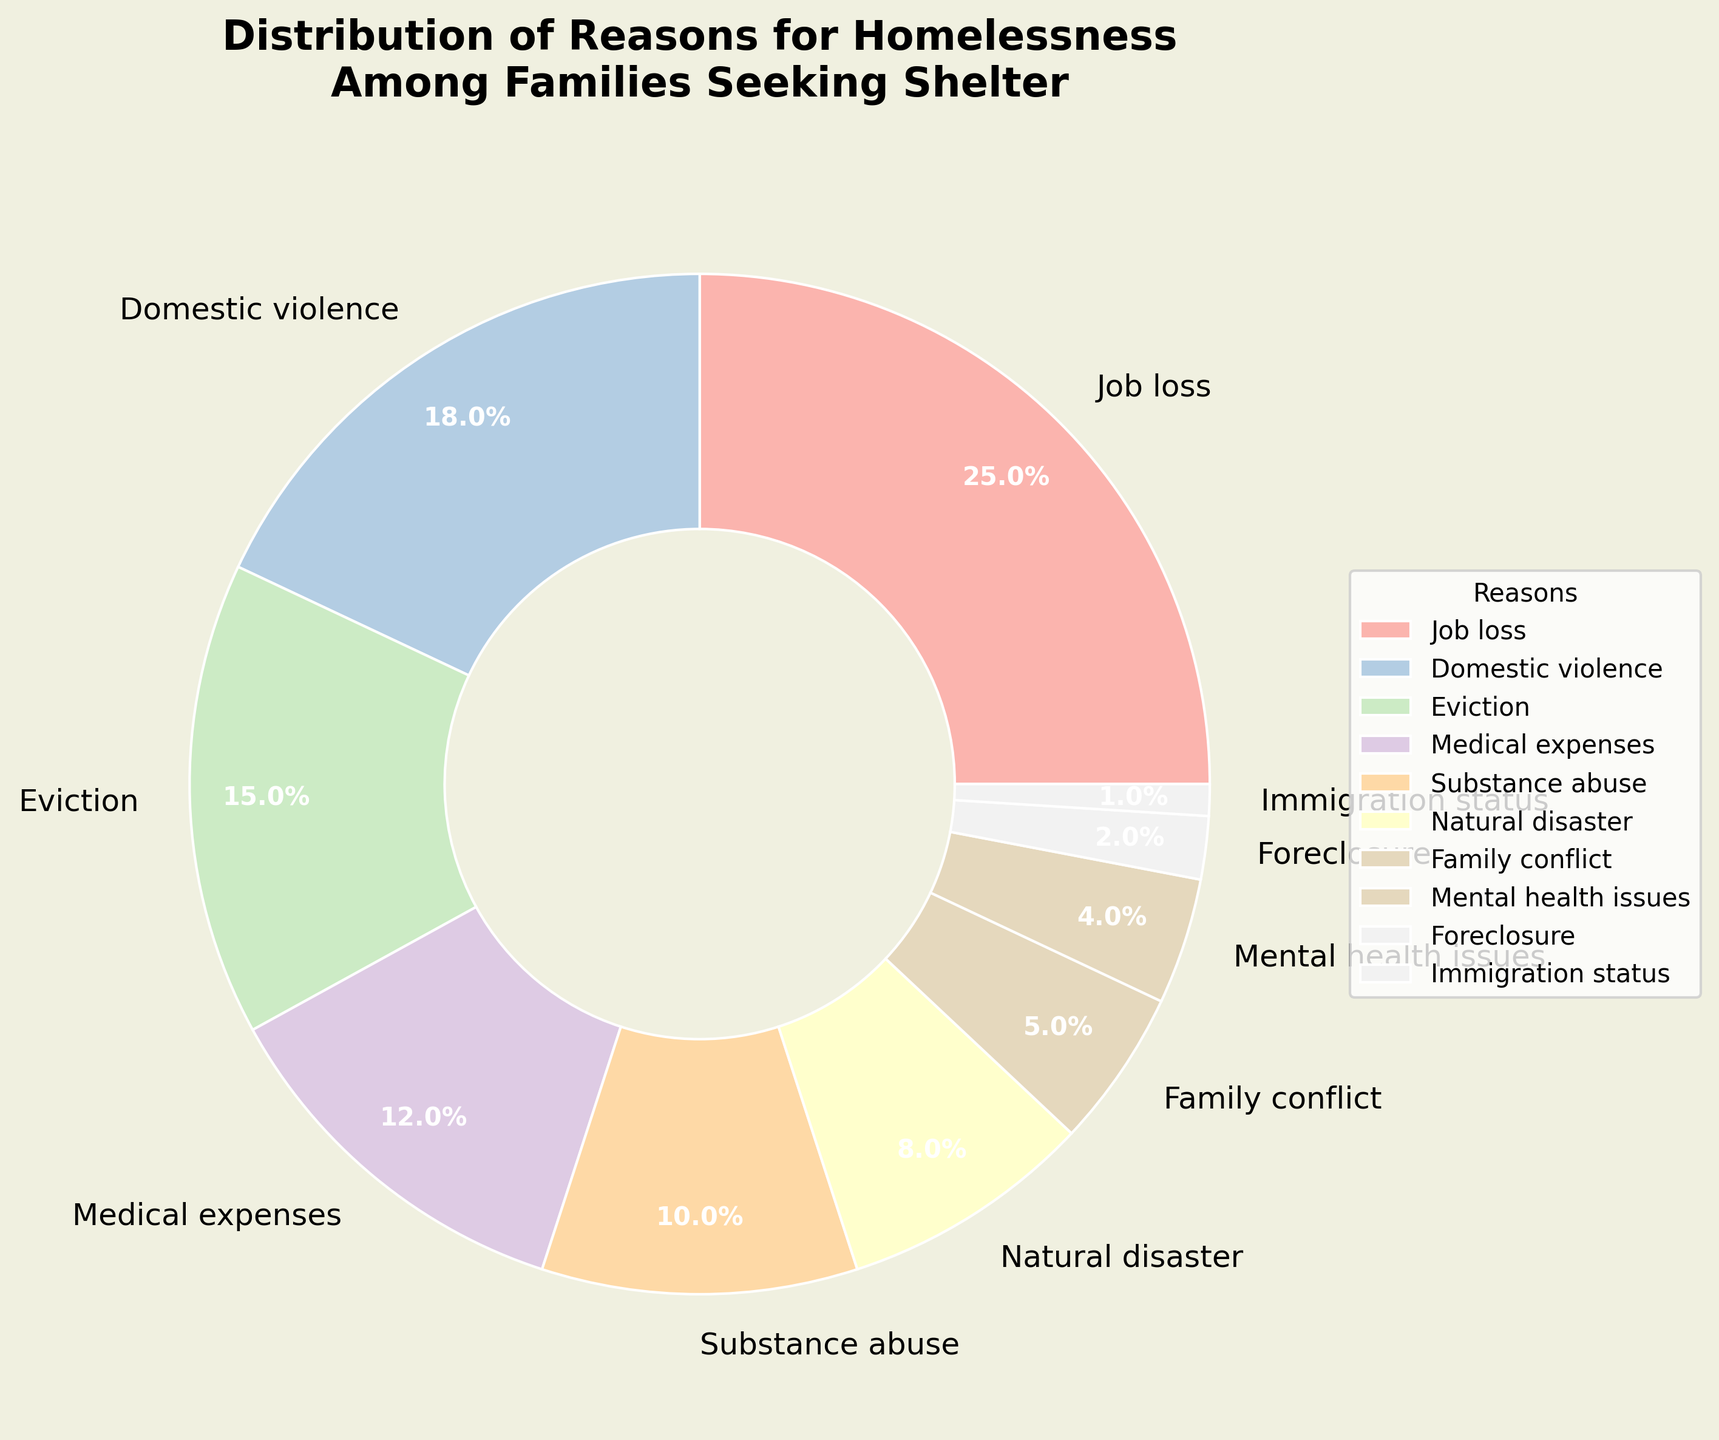What is the most common reason for homelessness among families seeking shelter? The most common reason will be the segment with the largest percentage on the pie chart. By looking at the figure, the segment labeled "Job loss" has the highest percentage at 25%.
Answer: Job loss What is the combined percentage of families experiencing homelessness due to medical expenses and natural disasters? We sum the percentages for medical expenses and natural disasters. According to the figure, medical expenses account for 12% and natural disasters 8%. So, the combined percentage is 12% + 8% = 20%.
Answer: 20% Which is more prevalent: eviction or substance abuse as a reason for homelessness? By comparing the percentages, eviction (15%) and substance abuse (10%), we see that eviction has a higher percentage.
Answer: Eviction What percentage of families are homeless due to reasons related to domestic violence or family conflict? Adding the percentages for domestic violence (18%) and family conflict (5%) results in 18% + 5% = 23%.
Answer: 23% Between mental health issues and immigration status, which reason affects fewer families? Comparing the percentages for mental health issues (4%) and immigration status (1%), immigration status has a lower percentage.
Answer: Immigration status Visualize the reasons that together account for over 50% of the families experiencing homelessness. Summing the percentages starting from the highest until we exceed 50%, we get Job loss (25%), Domestic violence (18%), and Eviction (15%). The total is 25% + 18% + 15% = 58%, covering the desired range.
Answer: Job loss, Domestic violence, Eviction What is the difference in percentage between families homeless due to job loss and those due to domestic violence? Subtracting the percentage for domestic violence (18%) from that for job loss (25%) gives us 25% - 18% = 7%.
Answer: 7% How many reasons each account for less than 5% of families experiencing homelessness? We count the reasons with percentages less than 5%: Family conflict (5%), Mental health issues (4%), Foreclosure (2%), and Immigration status (1%). There are four such reasons in total.
Answer: 4 Which reason accounts for a slightly larger percentage: Medical expenses or Natural disaster? Comparing percentages for medical expenses (12%) and natural disaster (8%), medical expenses have a larger percentage.
Answer: Medical expenses If we were to combine the percentages of families homeless due to domestic violence, medical expenses, and substance abuse, what would the total be? Adding the percentages for domestic violence (18%), medical expenses (12%), and substance abuse (10%) gives us 18% + 12% + 10% = 40%.
Answer: 40% 